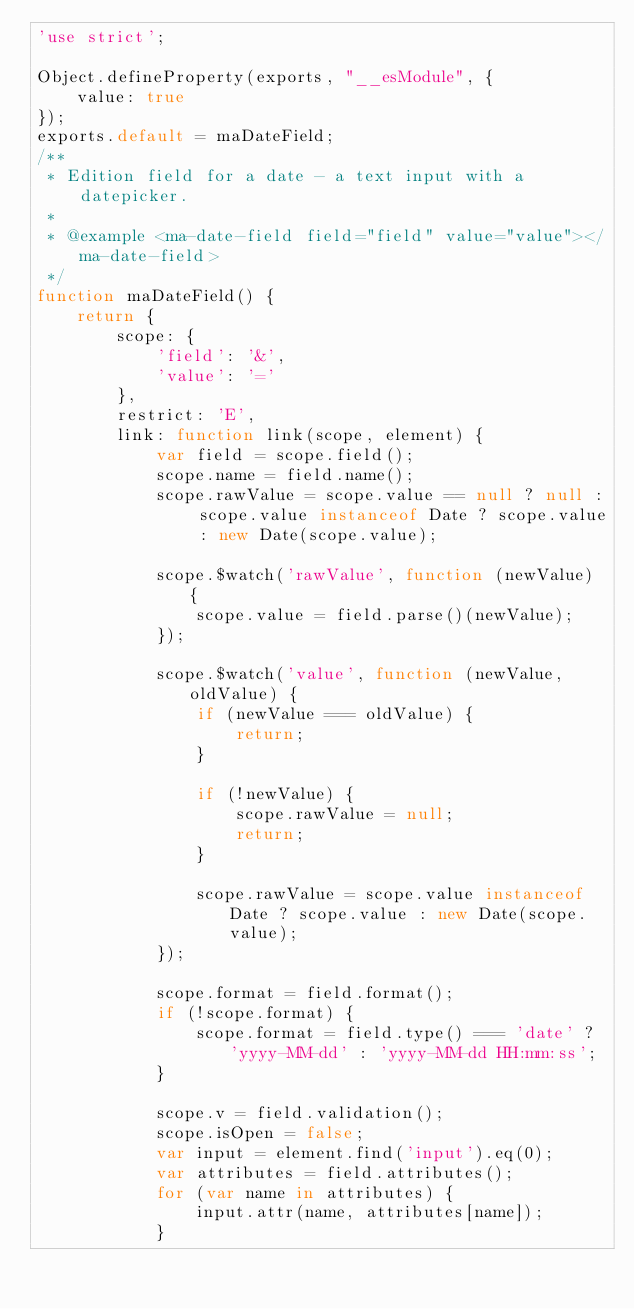Convert code to text. <code><loc_0><loc_0><loc_500><loc_500><_JavaScript_>'use strict';

Object.defineProperty(exports, "__esModule", {
    value: true
});
exports.default = maDateField;
/**
 * Edition field for a date - a text input with a datepicker.
 *
 * @example <ma-date-field field="field" value="value"></ma-date-field>
 */
function maDateField() {
    return {
        scope: {
            'field': '&',
            'value': '='
        },
        restrict: 'E',
        link: function link(scope, element) {
            var field = scope.field();
            scope.name = field.name();
            scope.rawValue = scope.value == null ? null : scope.value instanceof Date ? scope.value : new Date(scope.value);

            scope.$watch('rawValue', function (newValue) {
                scope.value = field.parse()(newValue);
            });

            scope.$watch('value', function (newValue, oldValue) {
                if (newValue === oldValue) {
                    return;
                }

                if (!newValue) {
                    scope.rawValue = null;
                    return;
                }

                scope.rawValue = scope.value instanceof Date ? scope.value : new Date(scope.value);
            });

            scope.format = field.format();
            if (!scope.format) {
                scope.format = field.type() === 'date' ? 'yyyy-MM-dd' : 'yyyy-MM-dd HH:mm:ss';
            }

            scope.v = field.validation();
            scope.isOpen = false;
            var input = element.find('input').eq(0);
            var attributes = field.attributes();
            for (var name in attributes) {
                input.attr(name, attributes[name]);
            }</code> 